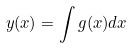Convert formula to latex. <formula><loc_0><loc_0><loc_500><loc_500>y ( x ) = \int g ( x ) d x</formula> 